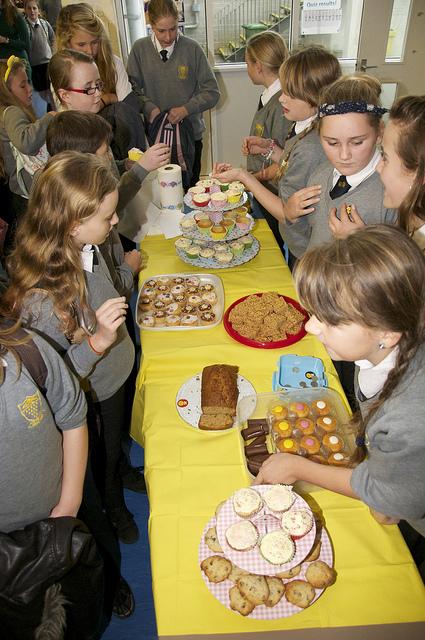What kind of food is served?
Concise answer only. Desserts. Is this a school bake sale?
Keep it brief. Yes. What color are the kids wearing?
Concise answer only. Gray. 